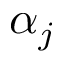Convert formula to latex. <formula><loc_0><loc_0><loc_500><loc_500>\alpha _ { j }</formula> 